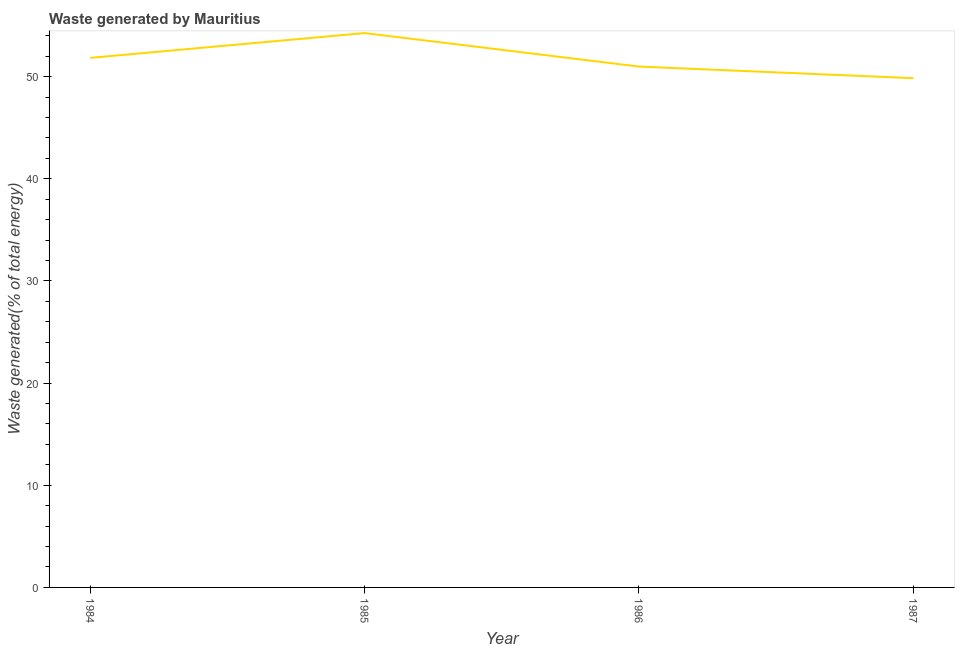What is the amount of waste generated in 1987?
Your answer should be compact. 49.85. Across all years, what is the maximum amount of waste generated?
Provide a short and direct response. 54.27. Across all years, what is the minimum amount of waste generated?
Ensure brevity in your answer.  49.85. In which year was the amount of waste generated minimum?
Ensure brevity in your answer.  1987. What is the sum of the amount of waste generated?
Your response must be concise. 206.96. What is the difference between the amount of waste generated in 1986 and 1987?
Offer a very short reply. 1.14. What is the average amount of waste generated per year?
Provide a short and direct response. 51.74. What is the median amount of waste generated?
Offer a terse response. 51.42. In how many years, is the amount of waste generated greater than 18 %?
Give a very brief answer. 4. What is the ratio of the amount of waste generated in 1986 to that in 1987?
Make the answer very short. 1.02. Is the amount of waste generated in 1985 less than that in 1987?
Ensure brevity in your answer.  No. What is the difference between the highest and the second highest amount of waste generated?
Make the answer very short. 2.43. What is the difference between the highest and the lowest amount of waste generated?
Offer a very short reply. 4.42. In how many years, is the amount of waste generated greater than the average amount of waste generated taken over all years?
Your answer should be compact. 2. Does the amount of waste generated monotonically increase over the years?
Give a very brief answer. No. How many years are there in the graph?
Your response must be concise. 4. What is the difference between two consecutive major ticks on the Y-axis?
Your response must be concise. 10. Are the values on the major ticks of Y-axis written in scientific E-notation?
Provide a succinct answer. No. Does the graph contain any zero values?
Your answer should be very brief. No. What is the title of the graph?
Offer a terse response. Waste generated by Mauritius. What is the label or title of the X-axis?
Your response must be concise. Year. What is the label or title of the Y-axis?
Your response must be concise. Waste generated(% of total energy). What is the Waste generated(% of total energy) in 1984?
Make the answer very short. 51.84. What is the Waste generated(% of total energy) in 1985?
Provide a short and direct response. 54.27. What is the Waste generated(% of total energy) in 1986?
Ensure brevity in your answer.  50.99. What is the Waste generated(% of total energy) of 1987?
Your response must be concise. 49.85. What is the difference between the Waste generated(% of total energy) in 1984 and 1985?
Give a very brief answer. -2.43. What is the difference between the Waste generated(% of total energy) in 1984 and 1986?
Ensure brevity in your answer.  0.85. What is the difference between the Waste generated(% of total energy) in 1984 and 1987?
Make the answer very short. 1.99. What is the difference between the Waste generated(% of total energy) in 1985 and 1986?
Your response must be concise. 3.28. What is the difference between the Waste generated(% of total energy) in 1985 and 1987?
Ensure brevity in your answer.  4.42. What is the difference between the Waste generated(% of total energy) in 1986 and 1987?
Provide a succinct answer. 1.14. What is the ratio of the Waste generated(% of total energy) in 1984 to that in 1985?
Provide a succinct answer. 0.95. What is the ratio of the Waste generated(% of total energy) in 1984 to that in 1987?
Provide a succinct answer. 1.04. What is the ratio of the Waste generated(% of total energy) in 1985 to that in 1986?
Keep it short and to the point. 1.06. What is the ratio of the Waste generated(% of total energy) in 1985 to that in 1987?
Offer a very short reply. 1.09. What is the ratio of the Waste generated(% of total energy) in 1986 to that in 1987?
Offer a very short reply. 1.02. 